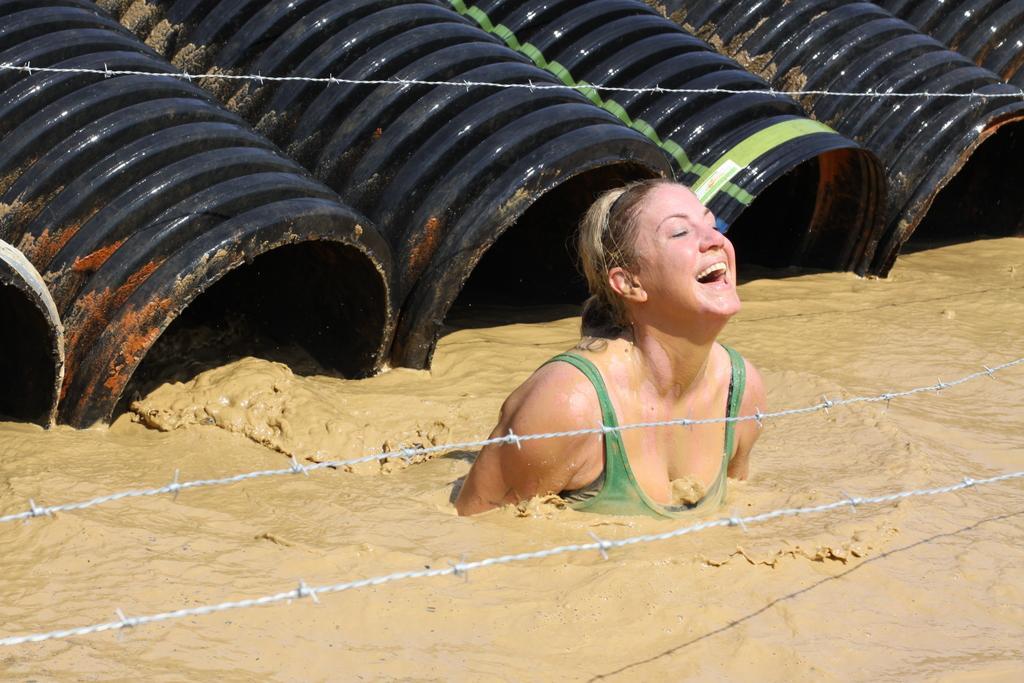Please provide a concise description of this image. In the center of the image we can see a lady is present in the water. In the background of the image we can see the fencing. At the top of the image we can see the drums. 